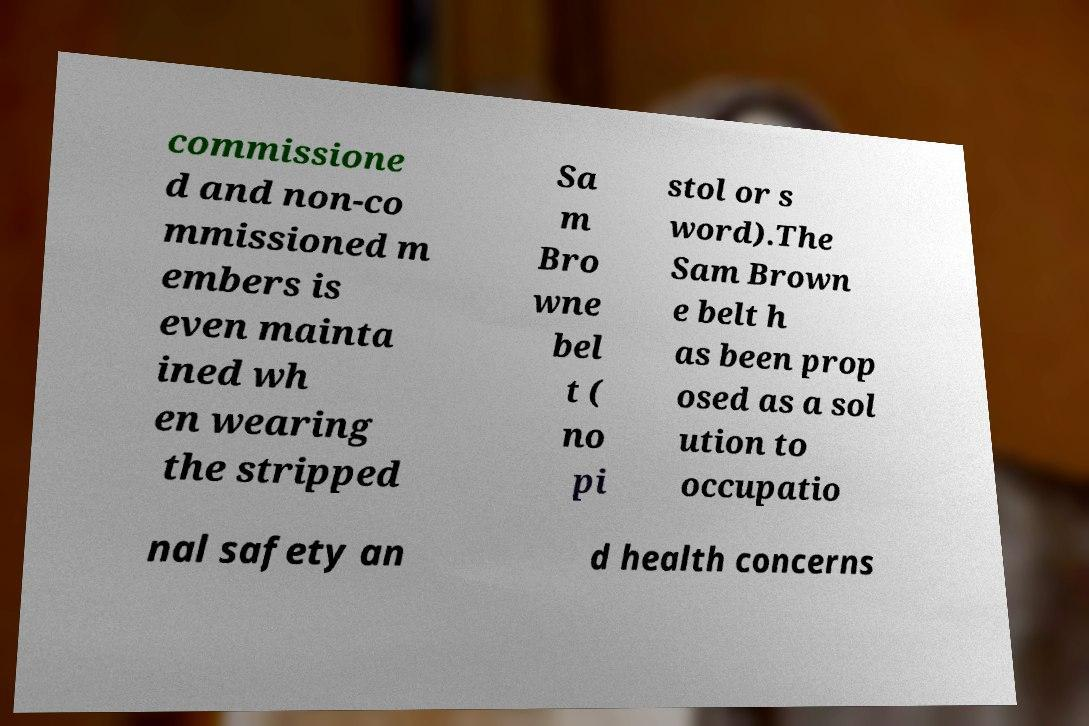Can you accurately transcribe the text from the provided image for me? commissione d and non-co mmissioned m embers is even mainta ined wh en wearing the stripped Sa m Bro wne bel t ( no pi stol or s word).The Sam Brown e belt h as been prop osed as a sol ution to occupatio nal safety an d health concerns 